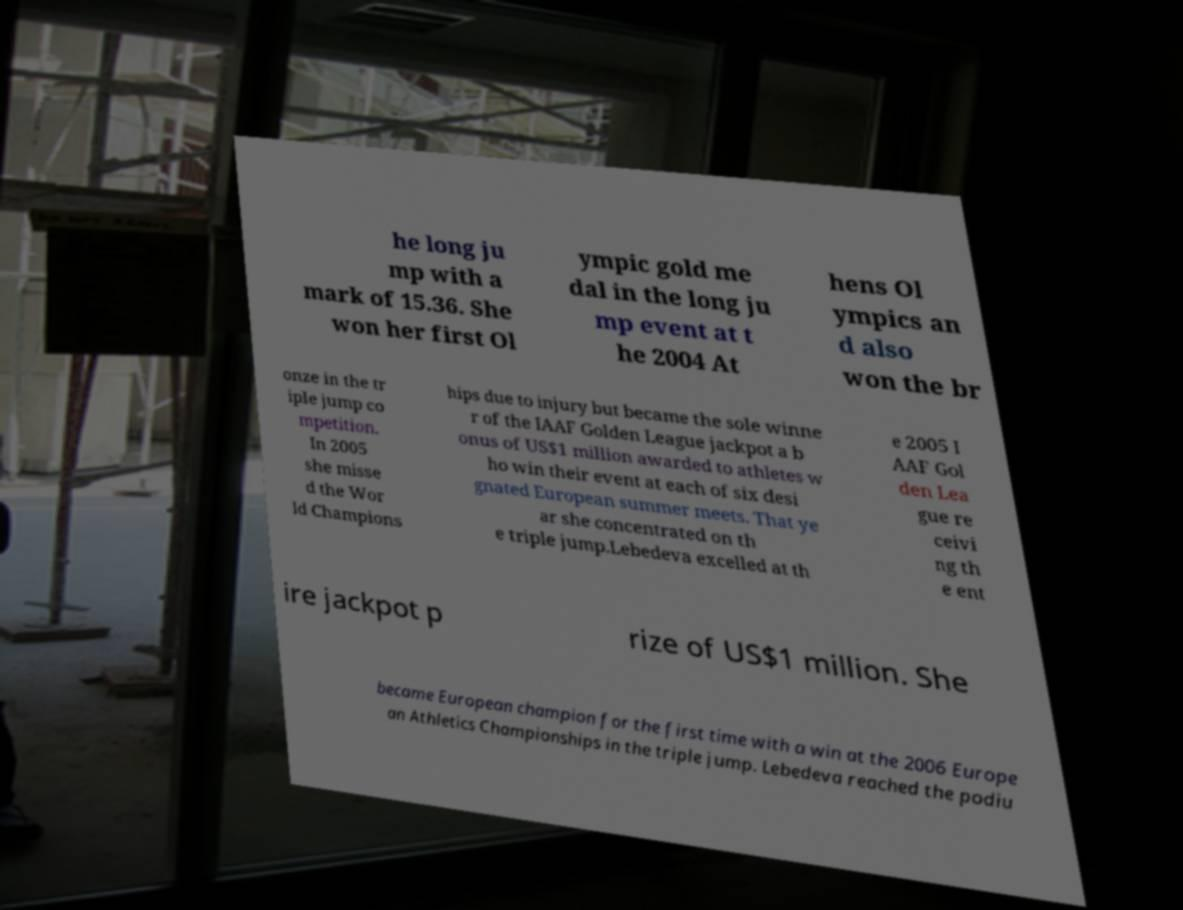Can you read and provide the text displayed in the image?This photo seems to have some interesting text. Can you extract and type it out for me? he long ju mp with a mark of 15.36. She won her first Ol ympic gold me dal in the long ju mp event at t he 2004 At hens Ol ympics an d also won the br onze in the tr iple jump co mpetition. In 2005 she misse d the Wor ld Champions hips due to injury but became the sole winne r of the IAAF Golden League jackpot a b onus of US$1 million awarded to athletes w ho win their event at each of six desi gnated European summer meets. That ye ar she concentrated on th e triple jump.Lebedeva excelled at th e 2005 I AAF Gol den Lea gue re ceivi ng th e ent ire jackpot p rize of US$1 million. She became European champion for the first time with a win at the 2006 Europe an Athletics Championships in the triple jump. Lebedeva reached the podiu 